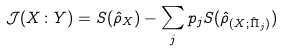<formula> <loc_0><loc_0><loc_500><loc_500>\mathcal { J } ( X \colon Y ) = S ( \hat { \rho } _ { X } ) - \sum _ { j } p _ { j } S ( \hat { \rho } _ { ( X ; \hat { \Pi } _ { j } ) } )</formula> 